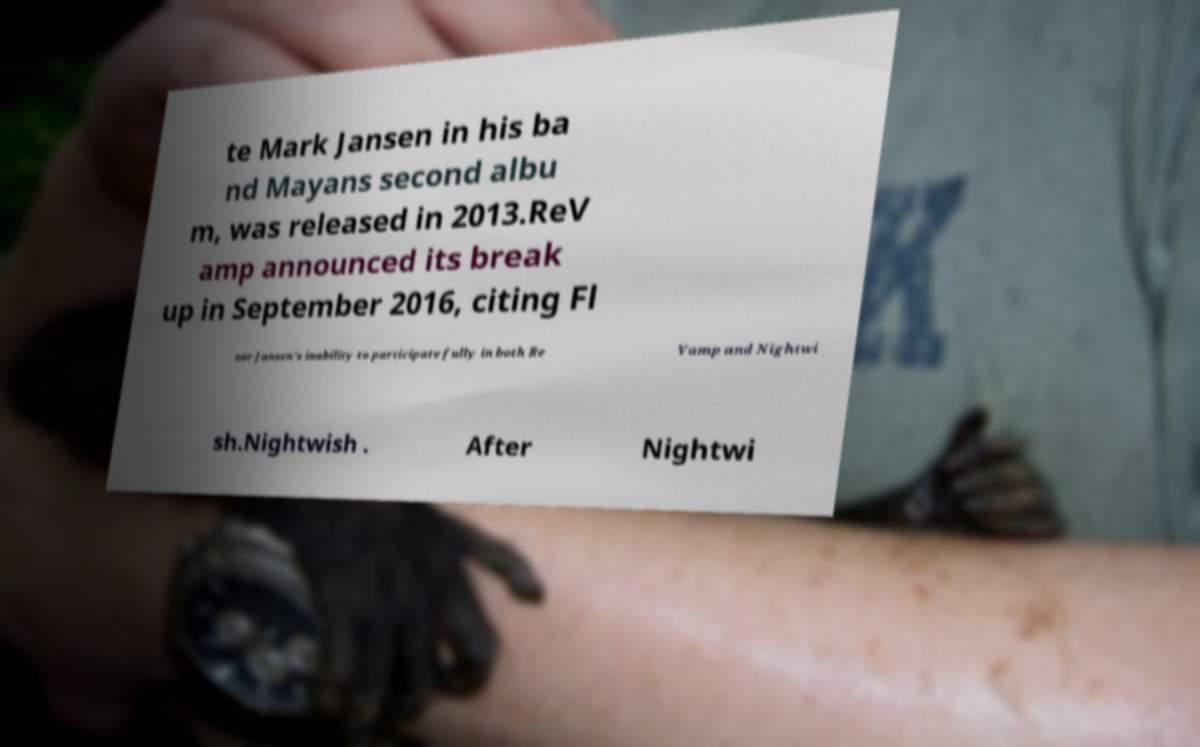For documentation purposes, I need the text within this image transcribed. Could you provide that? te Mark Jansen in his ba nd Mayans second albu m, was released in 2013.ReV amp announced its break up in September 2016, citing Fl oor Jansen's inability to participate fully in both Re Vamp and Nightwi sh.Nightwish . After Nightwi 